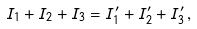<formula> <loc_0><loc_0><loc_500><loc_500>I _ { 1 } + I _ { 2 } + I _ { 3 } = I ^ { \prime } _ { 1 } + I ^ { \prime } _ { 2 } + I ^ { \prime } _ { 3 } \, ,</formula> 